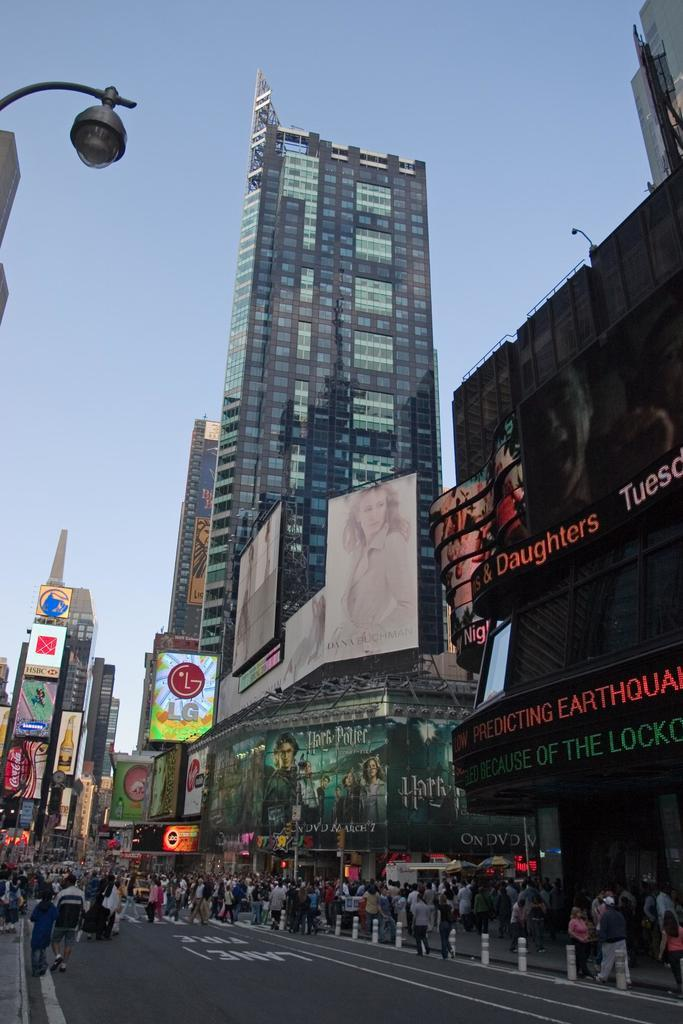Who or what can be seen in the image? There are people in the image. What can be seen in the background of the image? There are buildings with hoardings in the background. What type of windows do the buildings have? The buildings have glass windows. What is the color of the sky in the image? The sky is blue in color. Can you hear an argument taking place in the image? There is no indication of an argument in the image, as it only shows people, buildings, and a blue sky. 